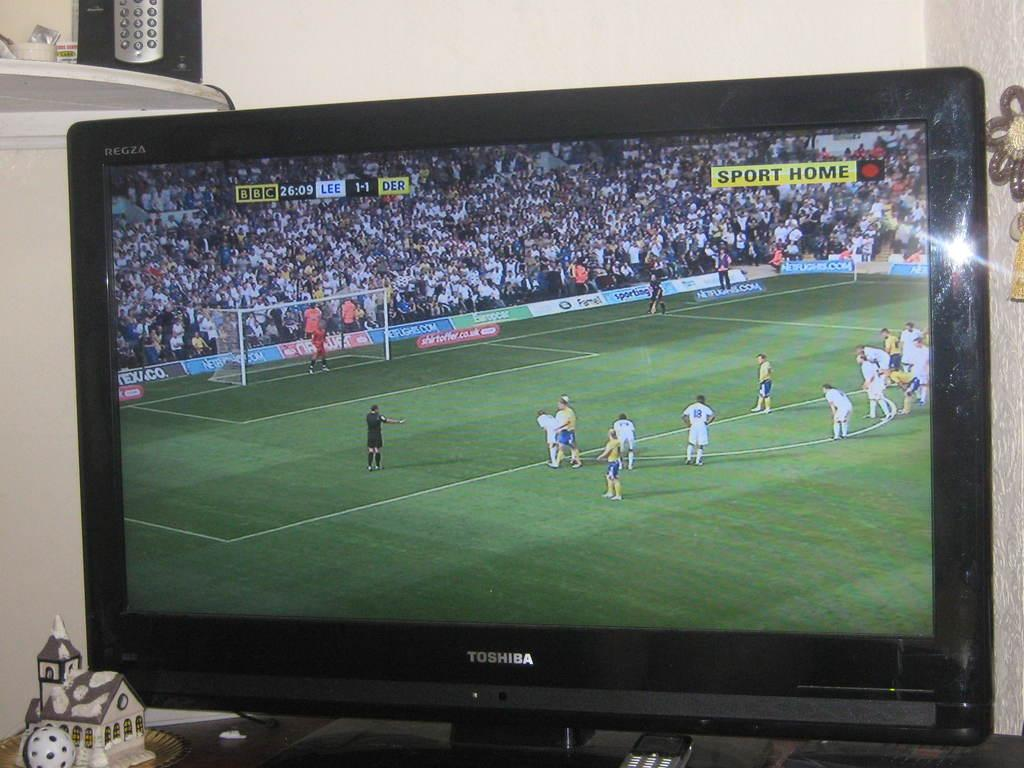Provide a one-sentence caption for the provided image. A soccer game is being shown on the Toshiba television. 